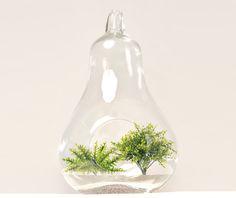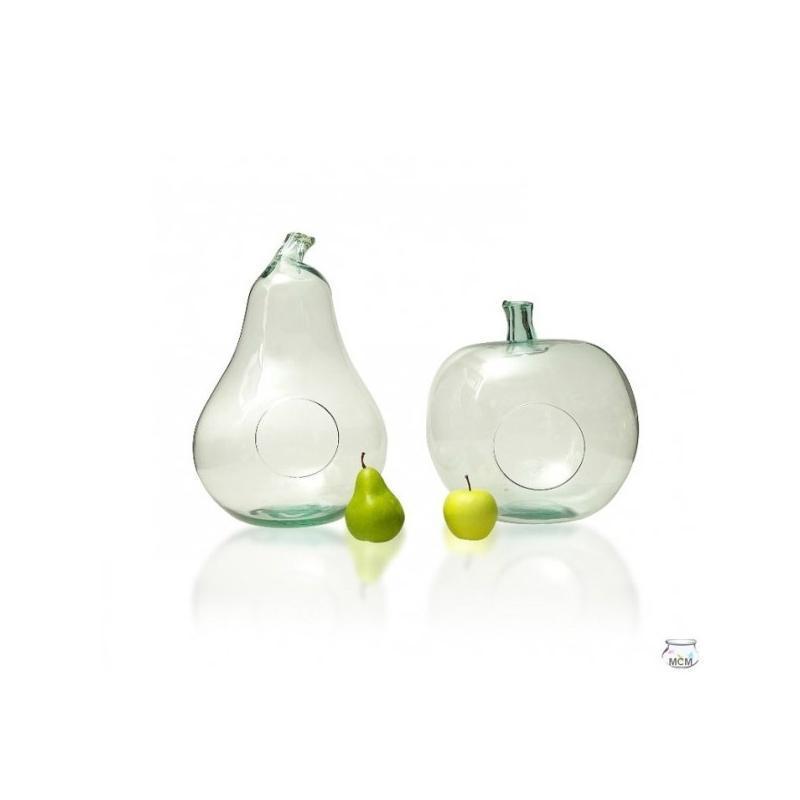The first image is the image on the left, the second image is the image on the right. Analyze the images presented: Is the assertion "In the right side image, there is a plant in only one of the vases." valid? Answer yes or no. No. The first image is the image on the left, the second image is the image on the right. Assess this claim about the two images: "There are 2 pieces of fruit sitting next to a vase.". Correct or not? Answer yes or no. Yes. 